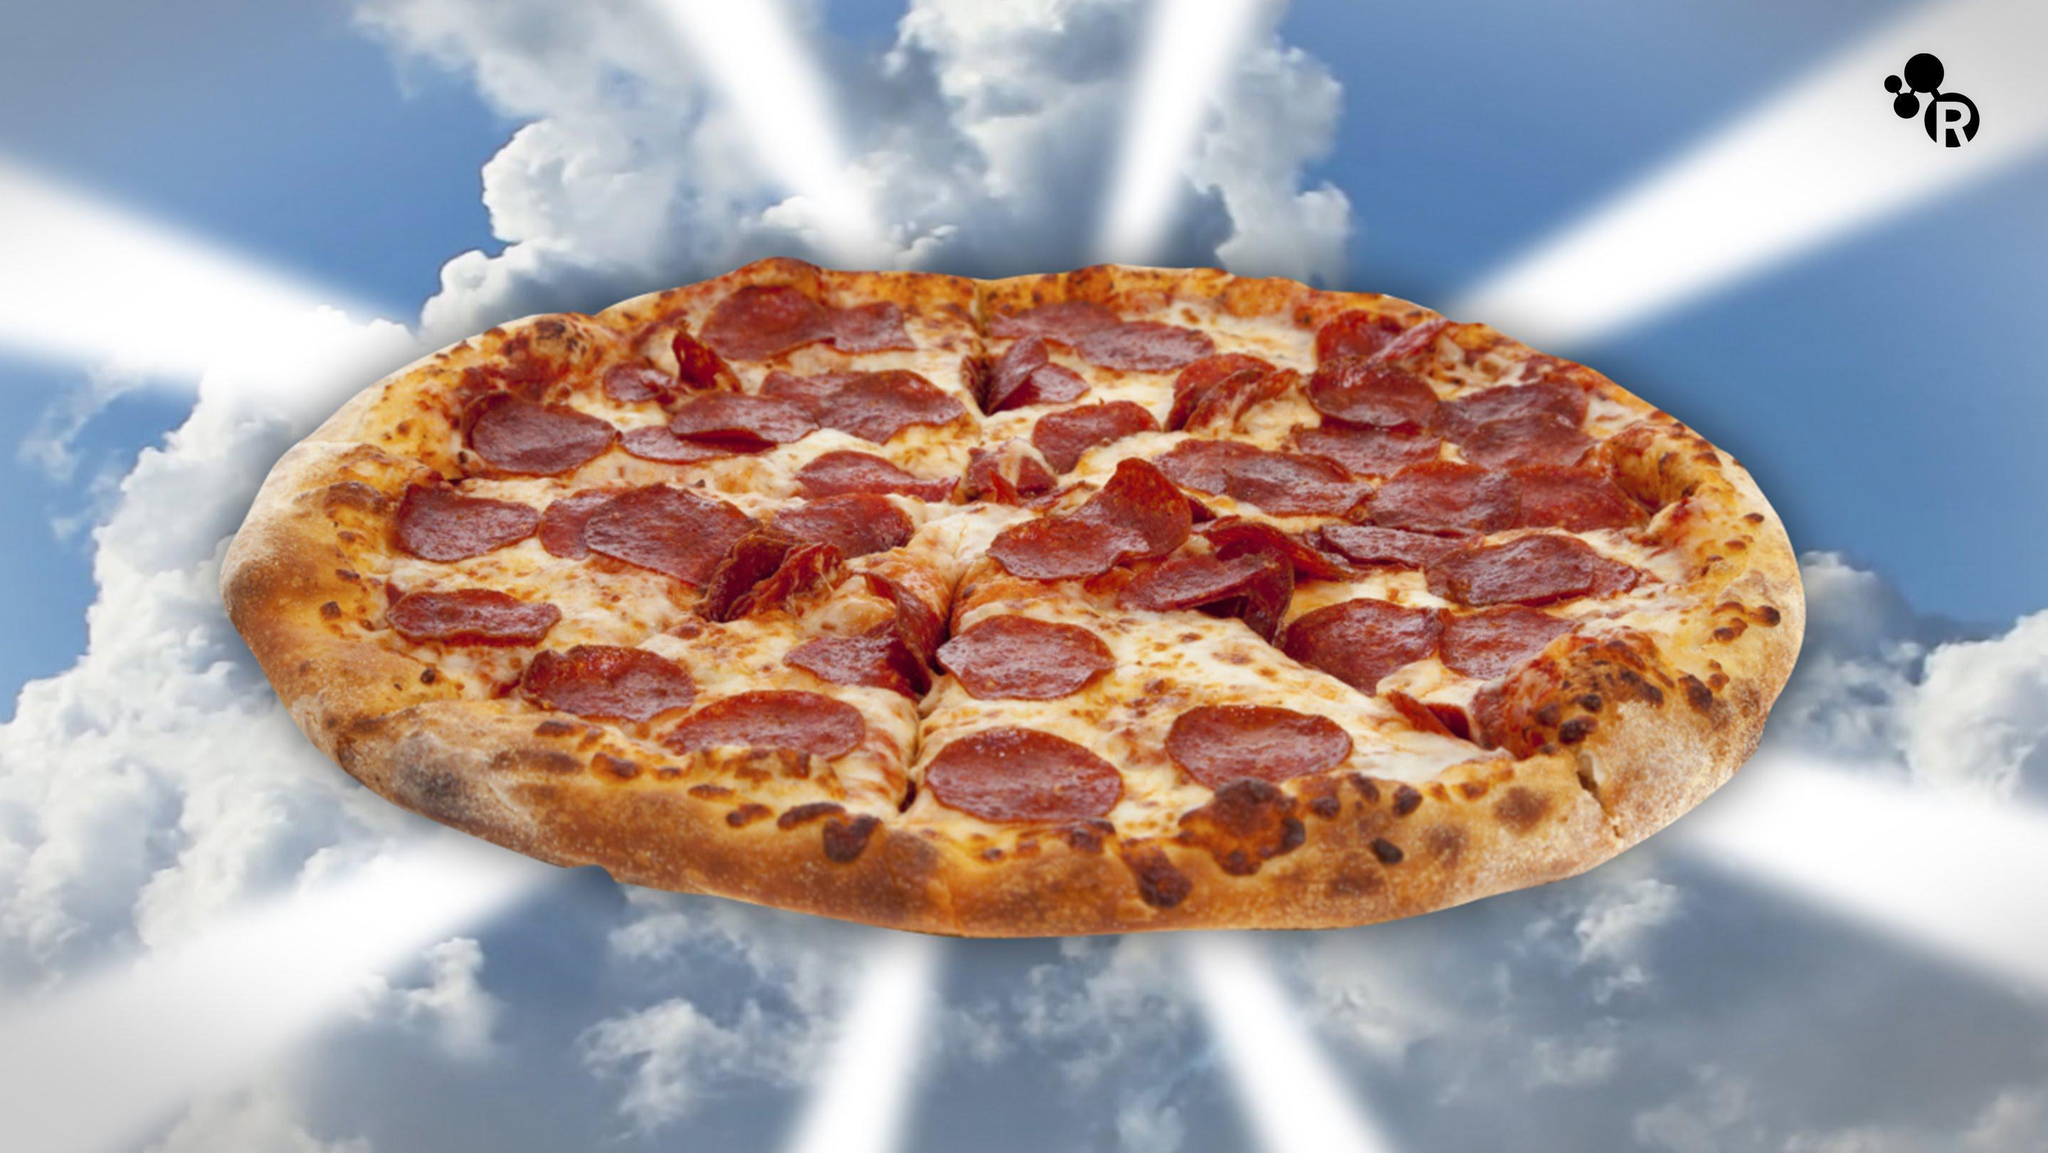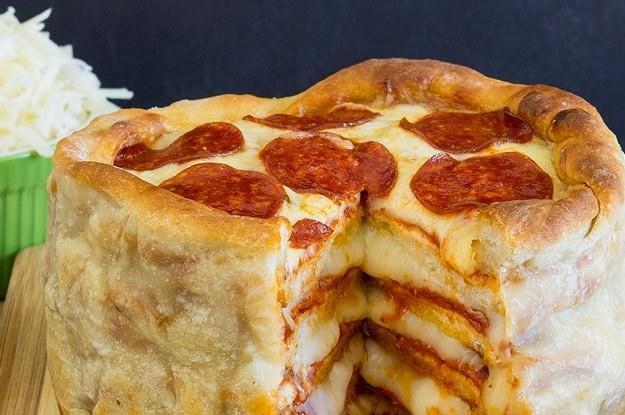The first image is the image on the left, the second image is the image on the right. Given the left and right images, does the statement "The right image shows one slice missing from a stuffed pizza, and the left image features at least one sliced pizza with no slices missing." hold true? Answer yes or no. Yes. The first image is the image on the left, the second image is the image on the right. Analyze the images presented: Is the assertion "There are three layers of pizza with at least one slice removed from the pie." valid? Answer yes or no. Yes. 